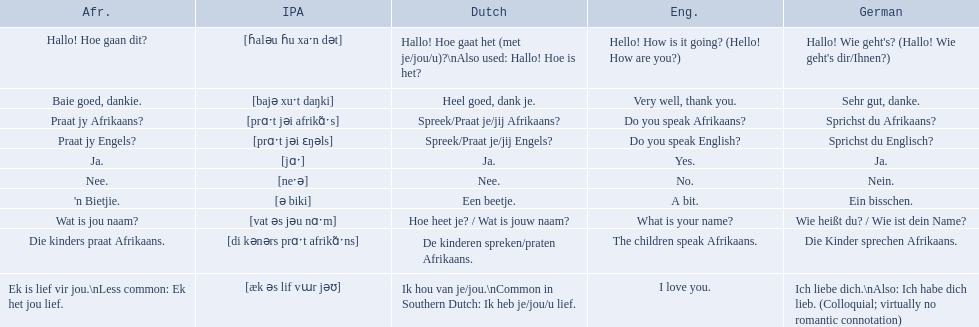What are all of the afrikaans phrases shown in the table? Hallo! Hoe gaan dit?, Baie goed, dankie., Praat jy Afrikaans?, Praat jy Engels?, Ja., Nee., 'n Bietjie., Wat is jou naam?, Die kinders praat Afrikaans., Ek is lief vir jou.\nLess common: Ek het jou lief. Of those, which translates into english as do you speak afrikaans?? Praat jy Afrikaans?. 